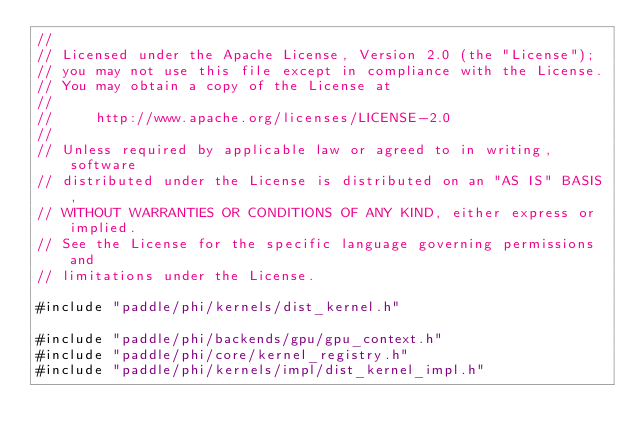Convert code to text. <code><loc_0><loc_0><loc_500><loc_500><_Cuda_>//
// Licensed under the Apache License, Version 2.0 (the "License");
// you may not use this file except in compliance with the License.
// You may obtain a copy of the License at
//
//     http://www.apache.org/licenses/LICENSE-2.0
//
// Unless required by applicable law or agreed to in writing, software
// distributed under the License is distributed on an "AS IS" BASIS,
// WITHOUT WARRANTIES OR CONDITIONS OF ANY KIND, either express or implied.
// See the License for the specific language governing permissions and
// limitations under the License.

#include "paddle/phi/kernels/dist_kernel.h"

#include "paddle/phi/backends/gpu/gpu_context.h"
#include "paddle/phi/core/kernel_registry.h"
#include "paddle/phi/kernels/impl/dist_kernel_impl.h"
</code> 